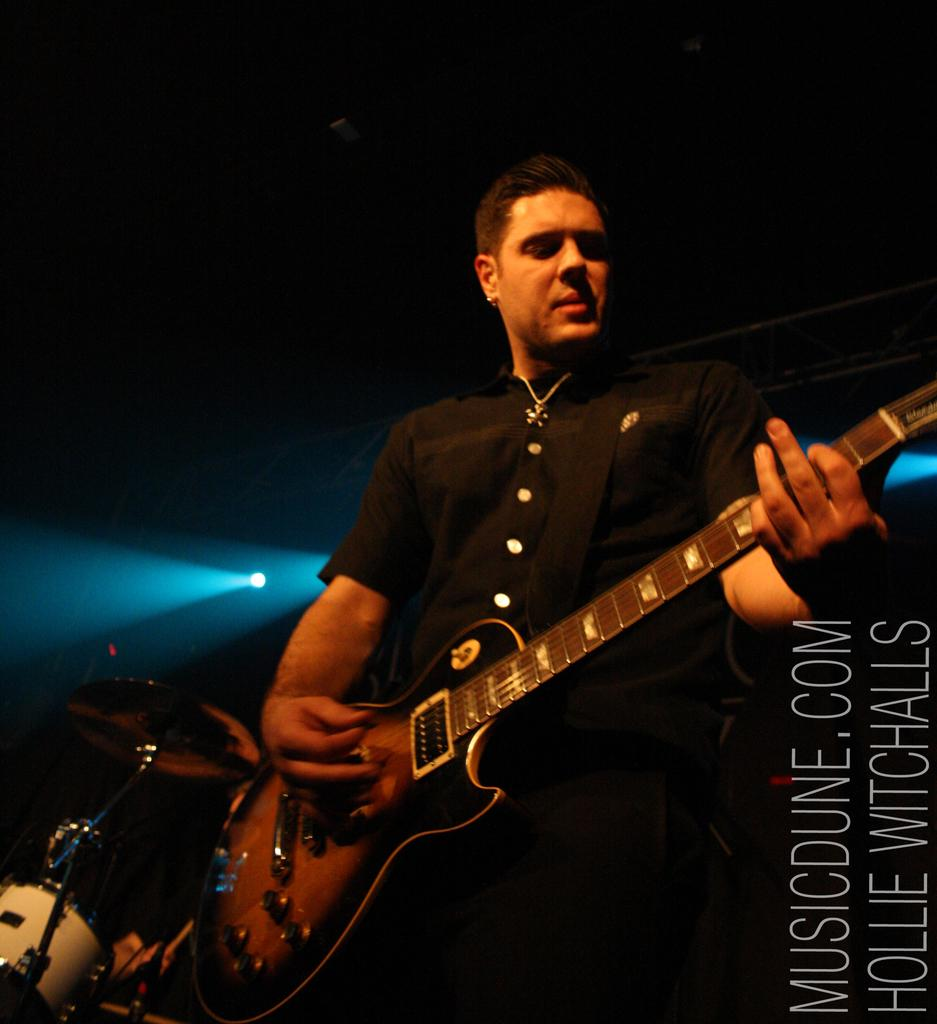Who is present in the image? There is a man in the image. What is the man doing in the image? The man is standing in the image. What object is the man holding in the image? The man is holding a guitar in his hands. What other musical instrument can be seen in the image? There are drums visible in the image. What can be used to provide illumination in the image? There is a light in the image. What type of turkey is being cooked on the guitar in the image? There is no turkey present in the image, nor is any cooking activity depicted. 